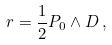<formula> <loc_0><loc_0><loc_500><loc_500>r = \frac { 1 } { 2 } P _ { 0 } \wedge D \, ,</formula> 